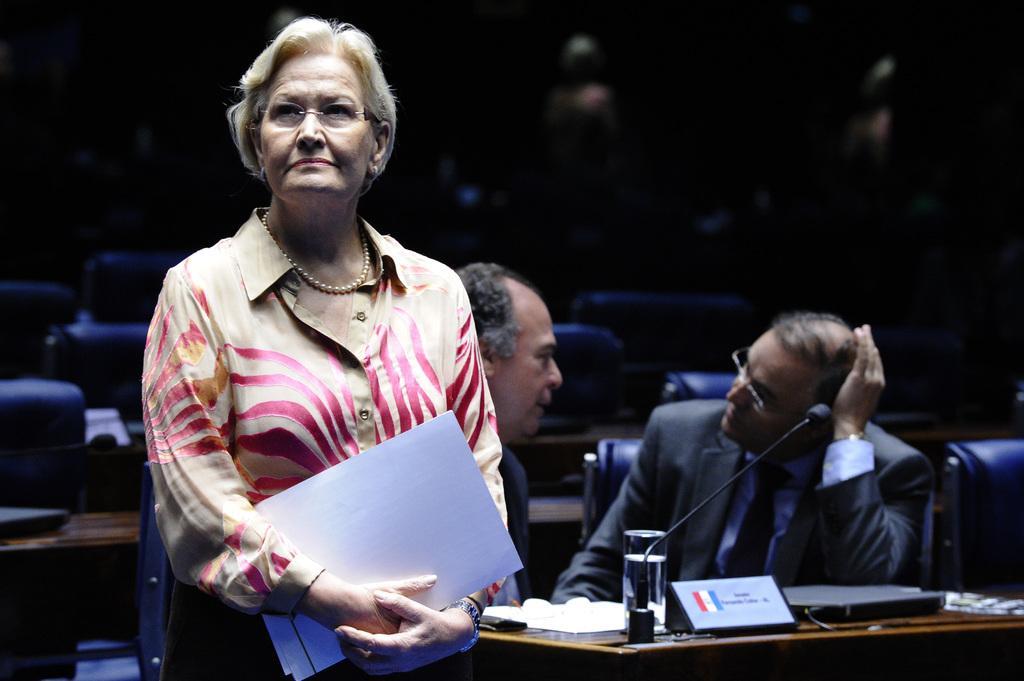Could you give a brief overview of what you see in this image? In the middle of the image a woman is standing and holding some papers. Behind her there is a table, on the table there is a microphone and glass and papers. Behind the table few people are sitting on chairs. 